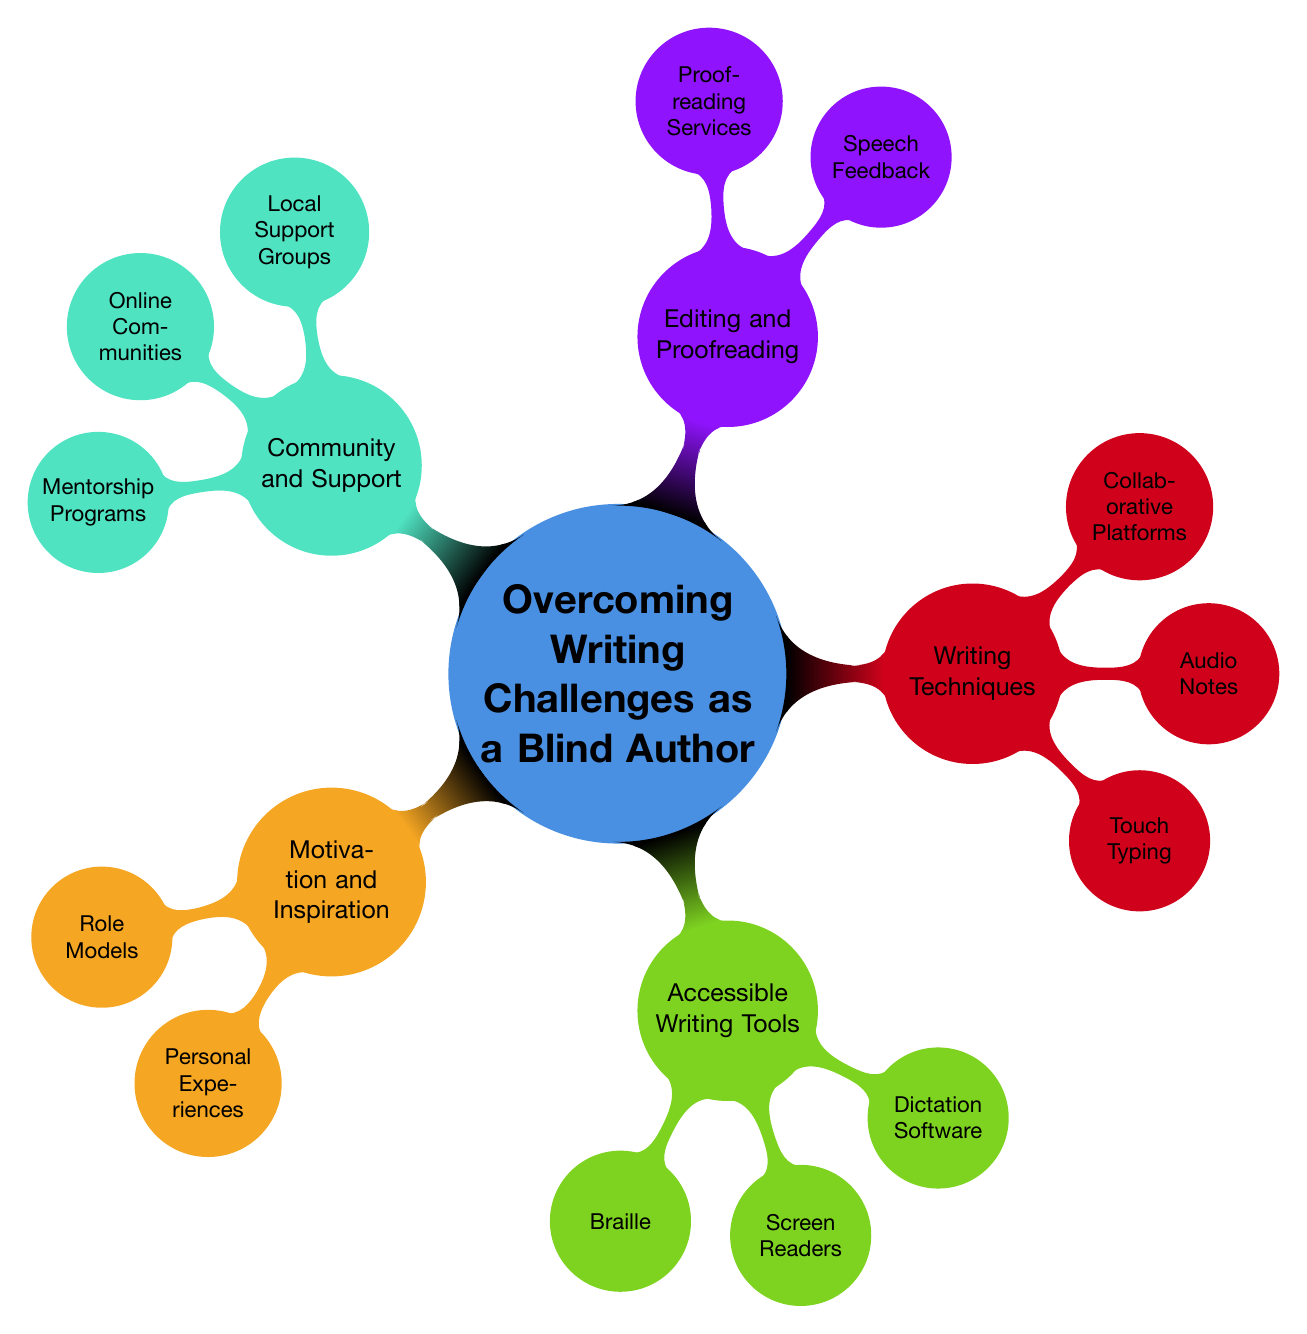What is the main topic of the mind map? The central topic of the mind map is labeled distinctly at the center node, which is "Overcoming Writing Challenges as a Blind Author".
Answer: Overcoming Writing Challenges as a Blind Author How many main branches are there in the diagram? The main branches are the primary categories highlighted around the central topic. There are five main branches: Motivation and Inspiration, Accessible Writing Tools, Writing Techniques, Editing and Proofreading, and Community and Support.
Answer: 5 What are the subcategories of Accessible Writing Tools? By examining the branch labeled "Accessible Writing Tools," it breaks down into three subcategories: Braille, Screen Readers, and Dictation Software.
Answer: Braille, Screen Readers, Dictation Software Which node includes the role models for blind authors? Looking at the "Motivation and Inspiration" branch, it contains a sub-node labeled "Role Models" that specifically lists influential figures.
Answer: Role Models What type of writing aid is suggested under Dictation Software? Within the "Accessible Writing Tools" section, specifically under "Dictation Software," two examples are provided: "Dragon NaturallySpeaking" and "Apple Dictation."
Answer: Dictation Software How many types of Community and Support are mentioned? The "Community and Support" branch further divides into three distinct types of support: Local Support Groups, Online Communities, and Mentorship Programs.
Answer: 3 Which specific tool is listed under Speech Feedback in Editing and Proofreading? The "Editing and Proofreading" section highlights a category called "Speech Feedback," which mentions "Text-to-Speech Tools" and "Human Assistants." Thus, one specific tool mentioned is "Text-to-Speech Tools."
Answer: Text-to-Speech Tools What relationship is there between Writing Techniques and Audio Notes? Both "Writing Techniques" and "Audio Notes" are distinct parts on the same hierarchical level, indicating that "Audio Notes" is a specific technique used for overcoming writing challenges.
Answer: Audio Notes is a technique 